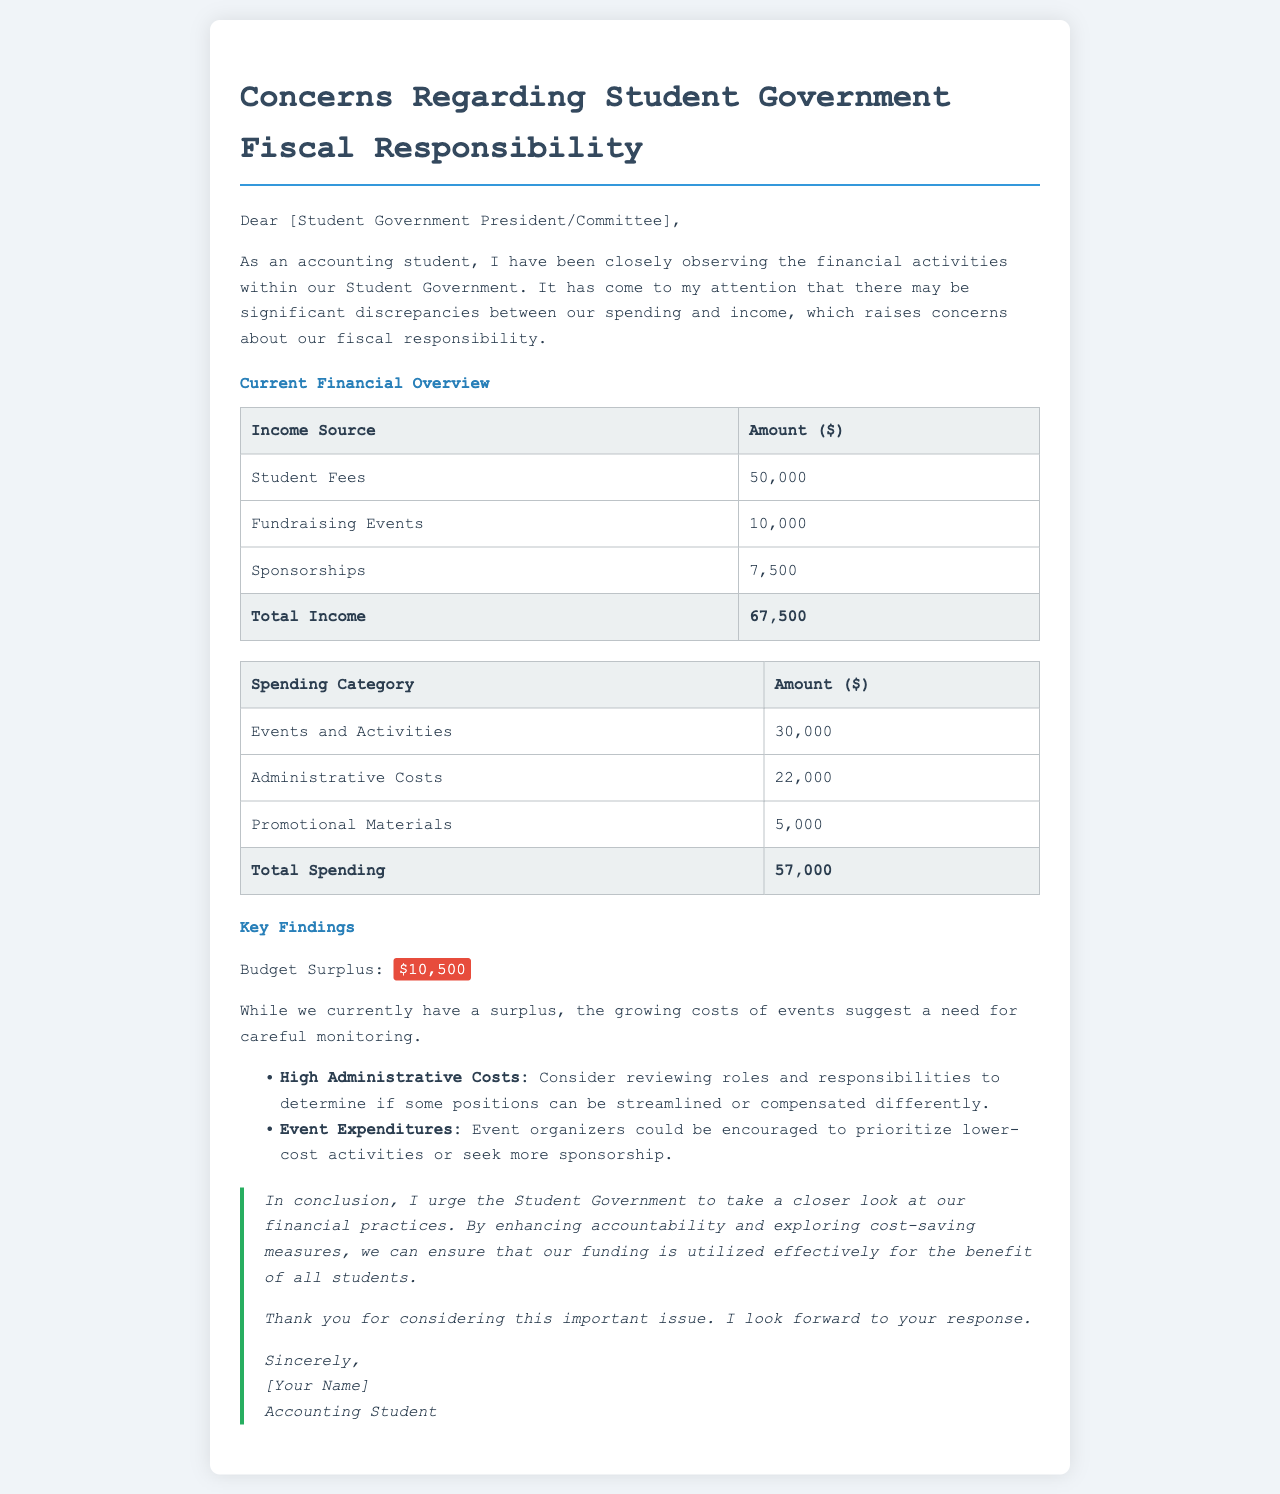What is the total income? The total income is summarized in one of the tables in the document, which totals the various income sources.
Answer: 67,500 What is the total spending? The total spending is the sum of all spending categories listed in the document which is shown in a table.
Answer: 57,000 What is the budget surplus? The budget surplus is a key finding indicated in the document, calculated by subtracting total spending from total income.
Answer: 10,500 What is the highest spending category? The document lists spending categories, which can be compared to identify the one with the highest amount.
Answer: Events and Activities What action is suggested for administrative costs? A recommendation related to administrative costs is made in the document based on the analysis presented.
Answer: Reviewing roles and responsibilities What is the lowest income source? The document provides a breakdown of income sources, and it's possible to identify the lowest by comparing their amounts.
Answer: Sponsorships What is the title of the document? The title is prominently displayed at the top of the letter, giving insight into its main focus.
Answer: Concerns Regarding Student Government Fiscal Responsibility What does the conclusion urge? The conclusion summarizes the main call to action based on the analysis throughout the document.
Answer: Enhancing accountability and exploring cost-saving measures What recommendation is made for event expenditures? The document includes suggestions for managing expenditures in a specific area, which can be found in the key findings.
Answer: Prioritize lower-cost activities 